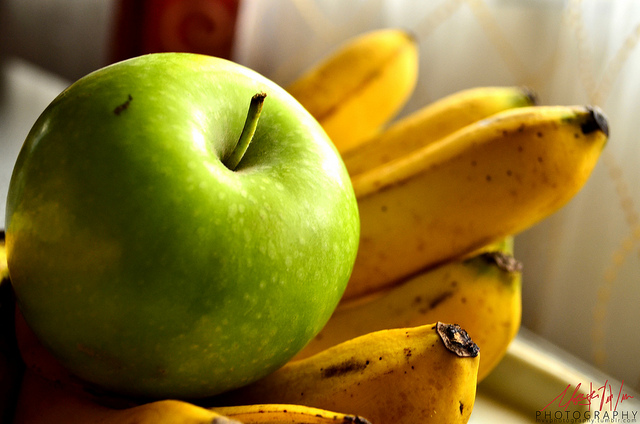Identify the text contained in this image. PHOTOGRAPHY PHOTOGRAPHY 